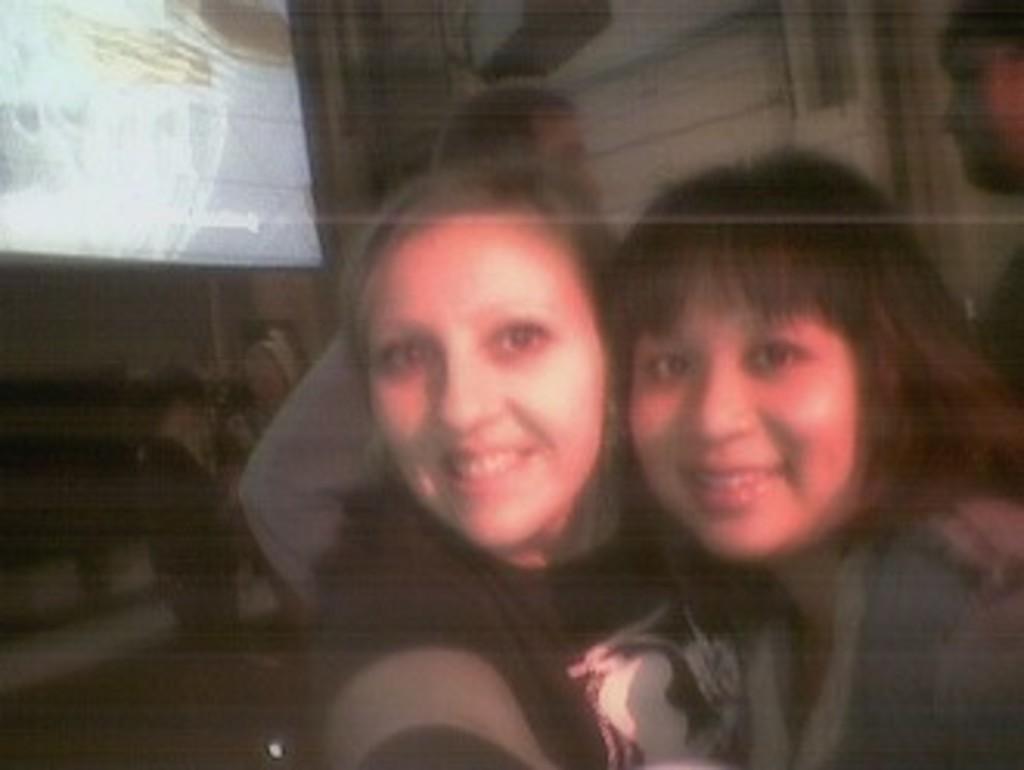Describe this image in one or two sentences. In this image we can see two ladies smiling. In the background there are people standing. On the left there is a board and a wall 